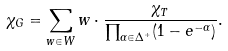<formula> <loc_0><loc_0><loc_500><loc_500>\chi _ { G } = \sum _ { w \in W } w \cdot \frac { \chi _ { T } } { \prod _ { \alpha \in \Delta ^ { + } } ( 1 - e ^ { - \alpha } ) } .</formula> 